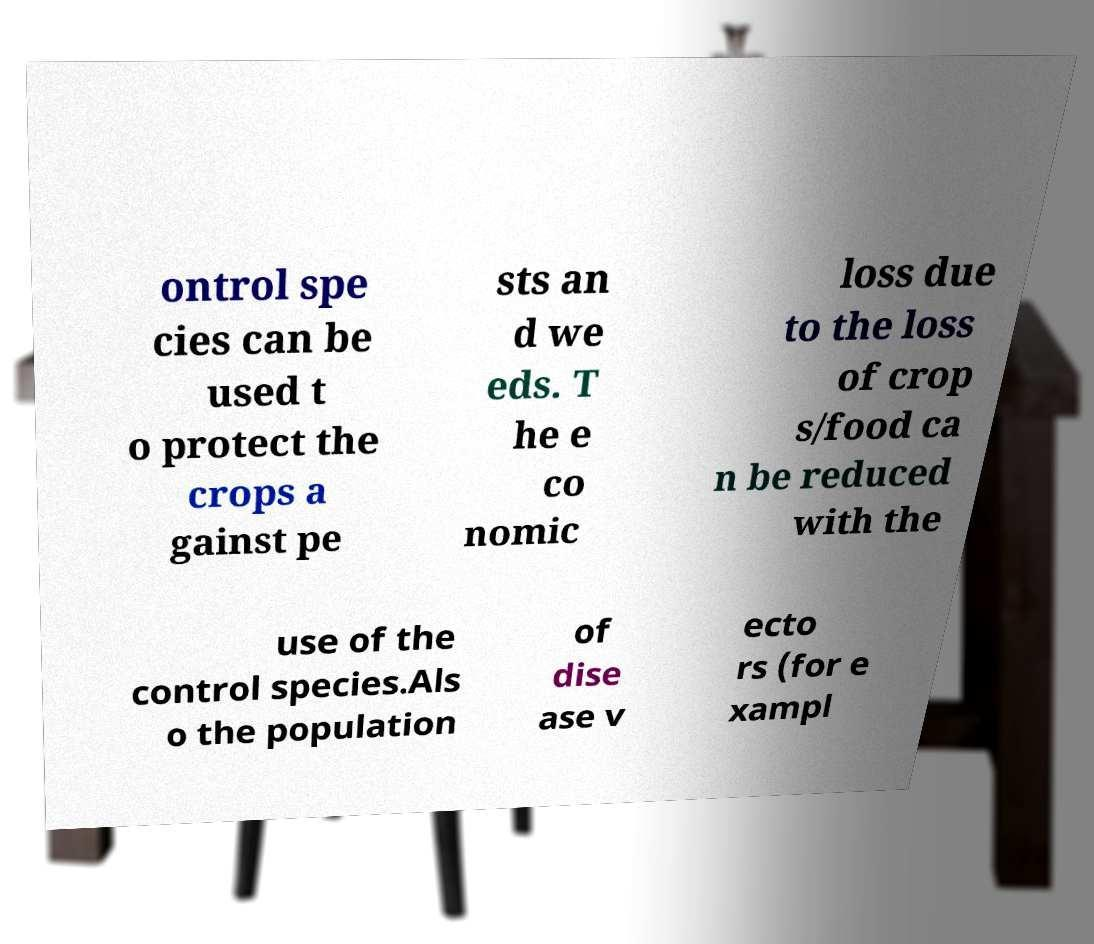Could you extract and type out the text from this image? ontrol spe cies can be used t o protect the crops a gainst pe sts an d we eds. T he e co nomic loss due to the loss of crop s/food ca n be reduced with the use of the control species.Als o the population of dise ase v ecto rs (for e xampl 